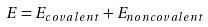<formula> <loc_0><loc_0><loc_500><loc_500>\ E = E _ { c o v a l e n t } + E _ { n o n c o v a l e n t }</formula> 